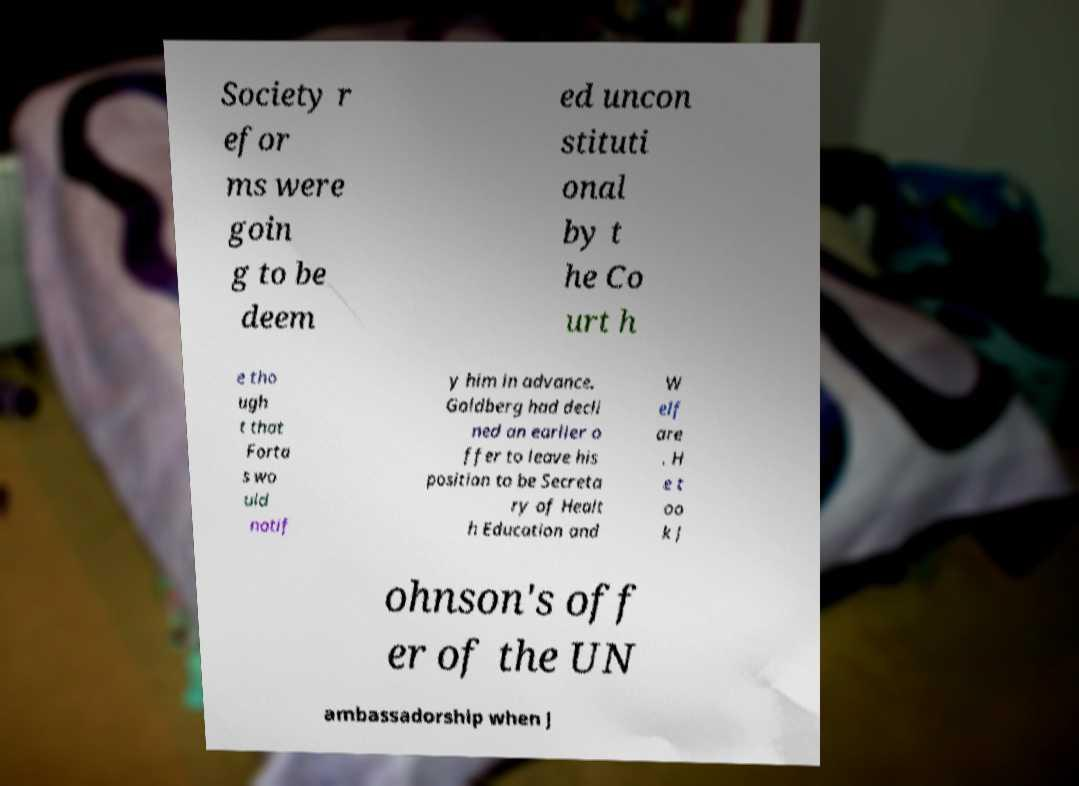Can you read and provide the text displayed in the image?This photo seems to have some interesting text. Can you extract and type it out for me? Society r efor ms were goin g to be deem ed uncon stituti onal by t he Co urt h e tho ugh t that Forta s wo uld notif y him in advance. Goldberg had decli ned an earlier o ffer to leave his position to be Secreta ry of Healt h Education and W elf are . H e t oo k J ohnson's off er of the UN ambassadorship when J 